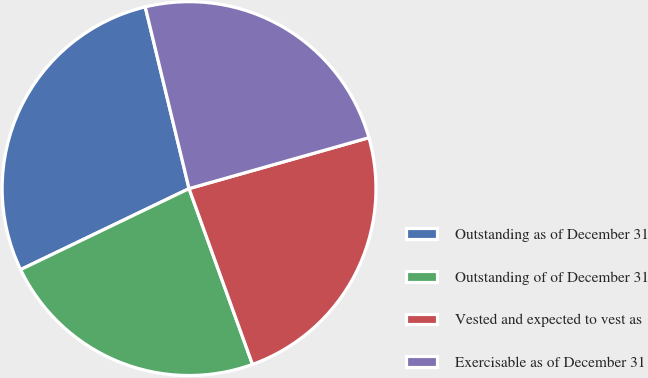<chart> <loc_0><loc_0><loc_500><loc_500><pie_chart><fcel>Outstanding as of December 31<fcel>Outstanding of of December 31<fcel>Vested and expected to vest as<fcel>Exercisable as of December 31<nl><fcel>28.37%<fcel>23.38%<fcel>23.88%<fcel>24.38%<nl></chart> 